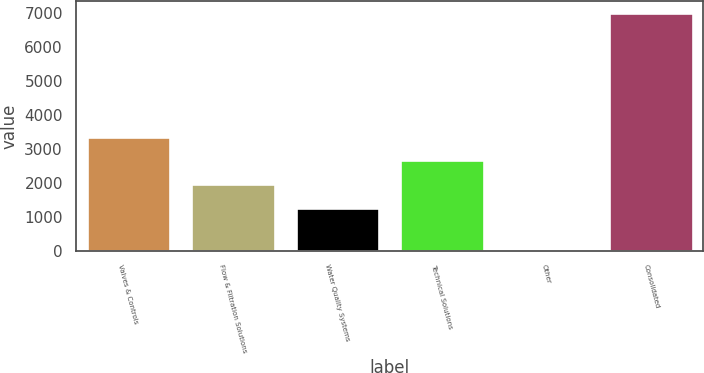Convert chart to OTSL. <chart><loc_0><loc_0><loc_500><loc_500><bar_chart><fcel>Valves & Controls<fcel>Flow & Filtration Solutions<fcel>Water Quality Systems<fcel>Technical Solutions<fcel>Other<fcel>Consolidated<nl><fcel>3358.26<fcel>1965.62<fcel>1269.3<fcel>2661.94<fcel>36.5<fcel>6999.7<nl></chart> 